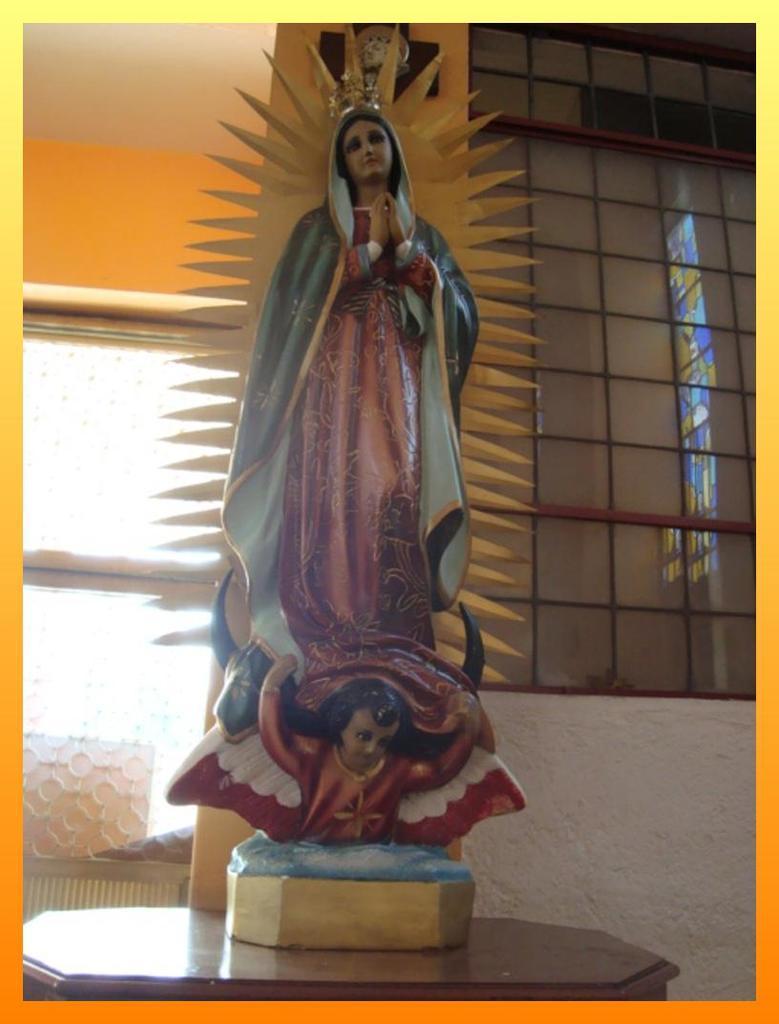Describe this image in one or two sentences. In this image there is a statue on the table, behind the statue there is a wall with mirrors. At the top of the image there is a ceiling and the clock is hanging on the wall. 